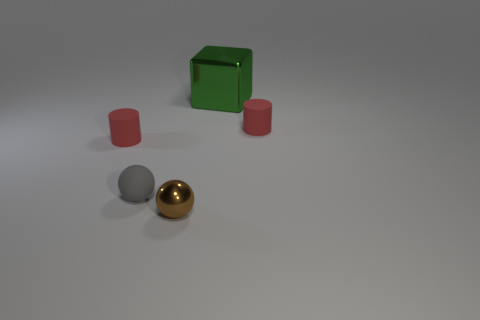Add 5 large green objects. How many objects exist? 10 Subtract all blocks. How many objects are left? 4 Subtract 1 green cubes. How many objects are left? 4 Subtract all big yellow things. Subtract all tiny red objects. How many objects are left? 3 Add 1 small brown shiny balls. How many small brown shiny balls are left? 2 Add 4 rubber blocks. How many rubber blocks exist? 4 